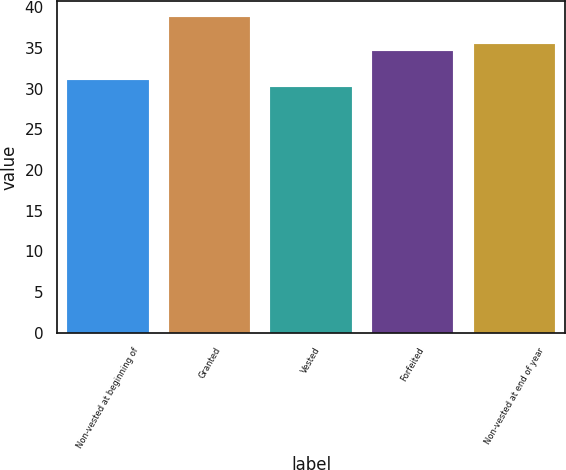Convert chart. <chart><loc_0><loc_0><loc_500><loc_500><bar_chart><fcel>Non-vested at beginning of<fcel>Granted<fcel>Vested<fcel>Forfeited<fcel>Non-vested at end of year<nl><fcel>31.09<fcel>38.84<fcel>30.23<fcel>34.68<fcel>35.54<nl></chart> 